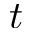<formula> <loc_0><loc_0><loc_500><loc_500>t</formula> 